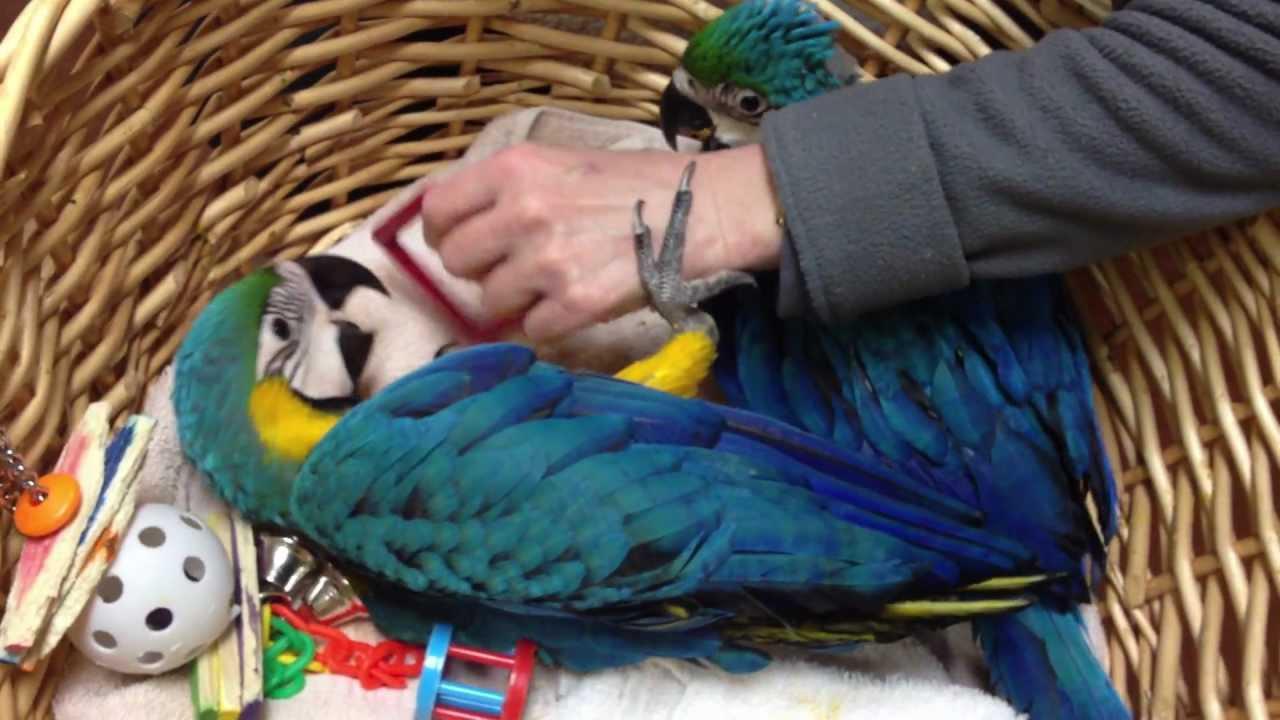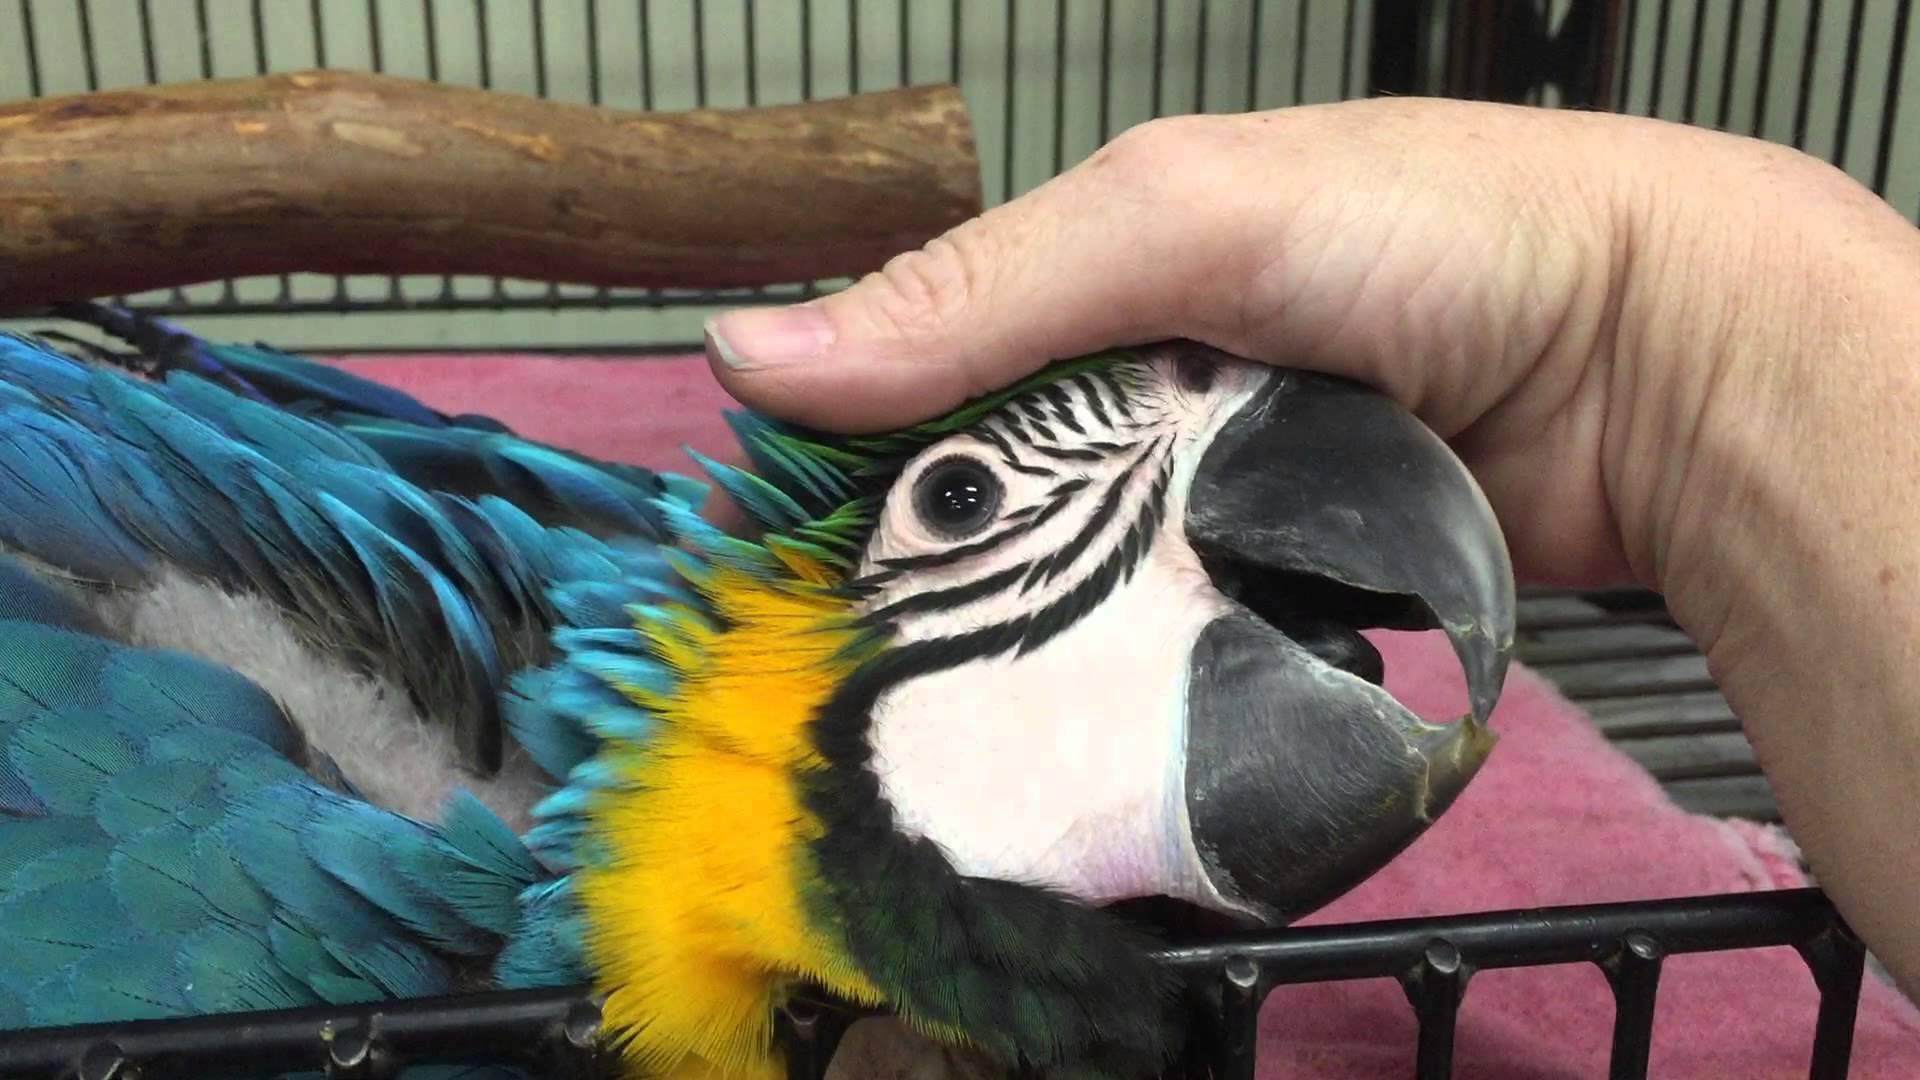The first image is the image on the left, the second image is the image on the right. Given the left and right images, does the statement "There are exactly four birds in total." hold true? Answer yes or no. No. The first image is the image on the left, the second image is the image on the right. Given the left and right images, does the statement "There are no less than three parrots resting on a branch." hold true? Answer yes or no. No. 